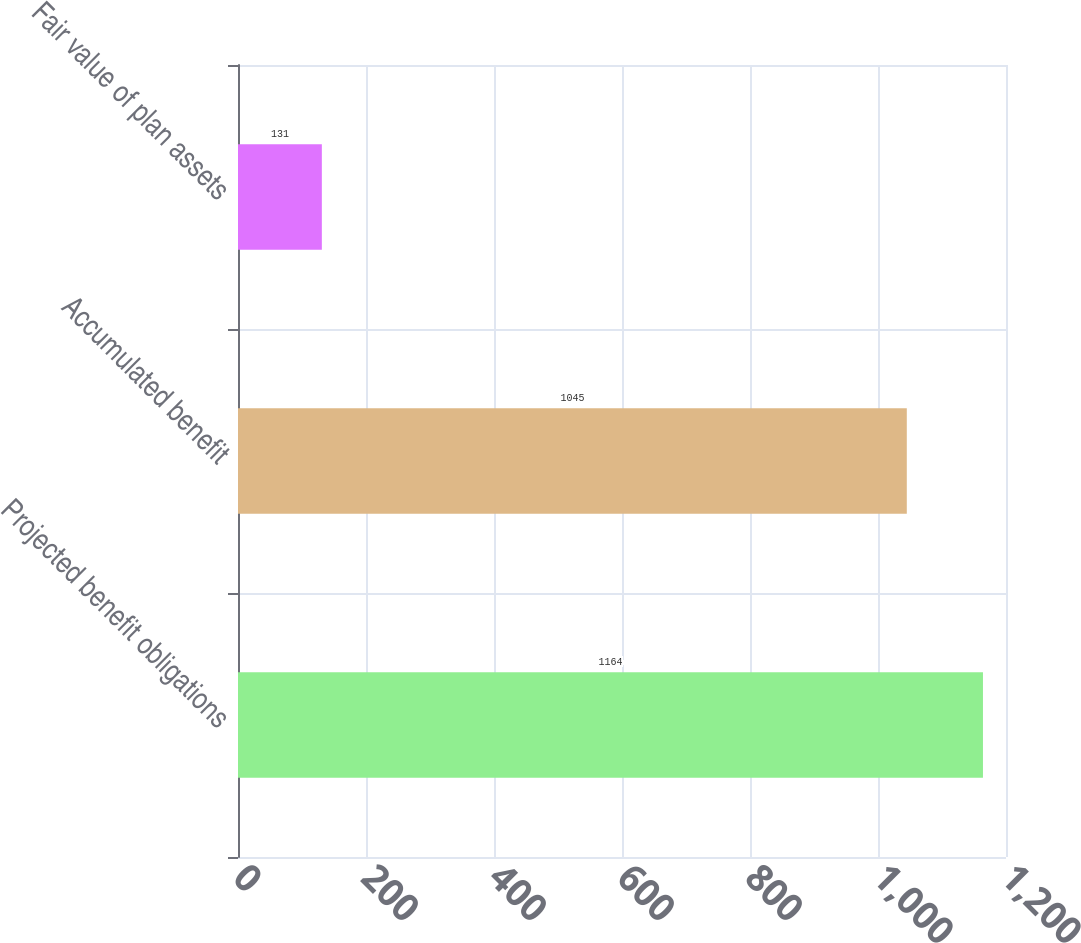<chart> <loc_0><loc_0><loc_500><loc_500><bar_chart><fcel>Projected benefit obligations<fcel>Accumulated benefit<fcel>Fair value of plan assets<nl><fcel>1164<fcel>1045<fcel>131<nl></chart> 